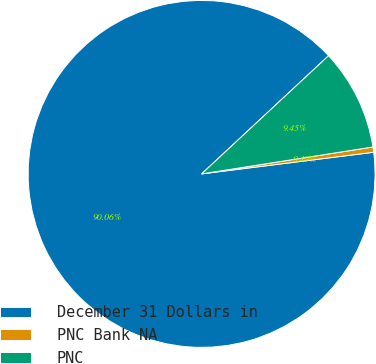Convert chart. <chart><loc_0><loc_0><loc_500><loc_500><pie_chart><fcel>December 31 Dollars in<fcel>PNC Bank NA<fcel>PNC<nl><fcel>90.06%<fcel>0.49%<fcel>9.45%<nl></chart> 